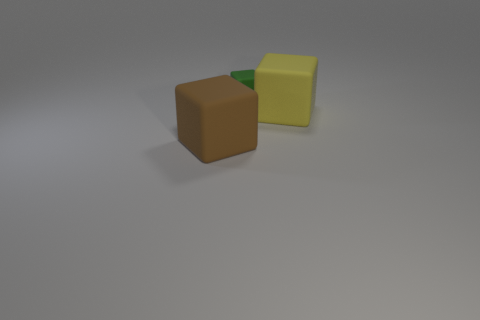Subtract all big brown matte cubes. How many cubes are left? 2 Add 3 large brown rubber cubes. How many objects exist? 6 Subtract all green cubes. How many cubes are left? 2 Subtract 2 blocks. How many blocks are left? 1 Add 2 big cyan matte balls. How many big cyan matte balls exist? 2 Subtract 1 yellow cubes. How many objects are left? 2 Subtract all yellow cubes. Subtract all purple cylinders. How many cubes are left? 2 Subtract all green cylinders. How many gray blocks are left? 0 Subtract all tiny blocks. Subtract all yellow cubes. How many objects are left? 1 Add 3 tiny green things. How many tiny green things are left? 4 